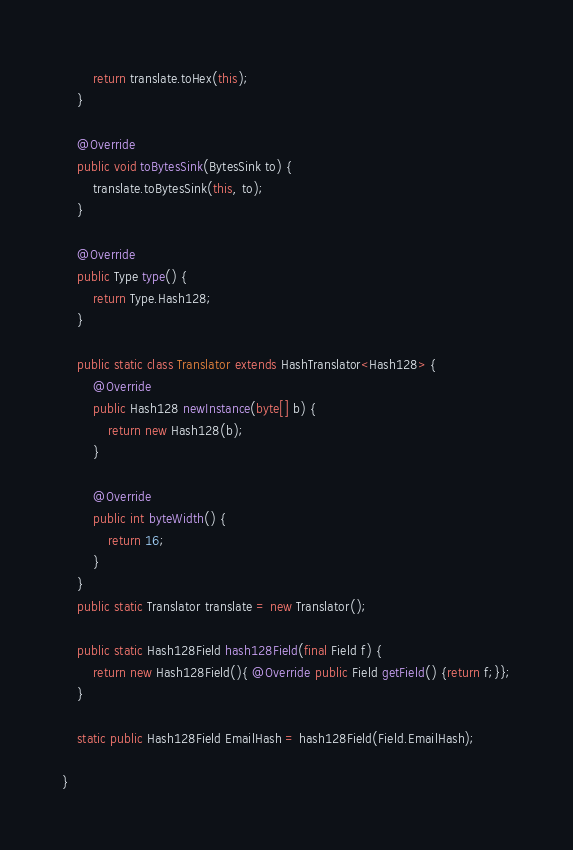<code> <loc_0><loc_0><loc_500><loc_500><_Java_>        return translate.toHex(this);
    }

    @Override
    public void toBytesSink(BytesSink to) {
        translate.toBytesSink(this, to);
    }

    @Override
    public Type type() {
        return Type.Hash128;
    }

    public static class Translator extends HashTranslator<Hash128> {
        @Override
        public Hash128 newInstance(byte[] b) {
            return new Hash128(b);
        }

        @Override
        public int byteWidth() {
            return 16;
        }
    }
    public static Translator translate = new Translator();

    public static Hash128Field hash128Field(final Field f) {
        return new Hash128Field(){ @Override public Field getField() {return f;}};
    }

    static public Hash128Field EmailHash = hash128Field(Field.EmailHash);

}
</code> 